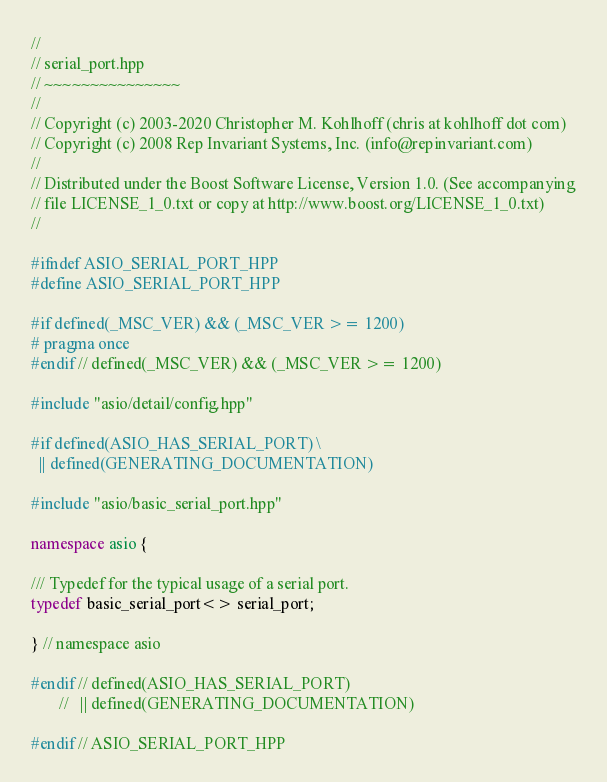<code> <loc_0><loc_0><loc_500><loc_500><_C++_>//
// serial_port.hpp
// ~~~~~~~~~~~~~~~
//
// Copyright (c) 2003-2020 Christopher M. Kohlhoff (chris at kohlhoff dot com)
// Copyright (c) 2008 Rep Invariant Systems, Inc. (info@repinvariant.com)
//
// Distributed under the Boost Software License, Version 1.0. (See accompanying
// file LICENSE_1_0.txt or copy at http://www.boost.org/LICENSE_1_0.txt)
//

#ifndef ASIO_SERIAL_PORT_HPP
#define ASIO_SERIAL_PORT_HPP

#if defined(_MSC_VER) && (_MSC_VER >= 1200)
# pragma once
#endif // defined(_MSC_VER) && (_MSC_VER >= 1200)

#include "asio/detail/config.hpp"

#if defined(ASIO_HAS_SERIAL_PORT) \
  || defined(GENERATING_DOCUMENTATION)

#include "asio/basic_serial_port.hpp"

namespace asio {

/// Typedef for the typical usage of a serial port.
typedef basic_serial_port<> serial_port;

} // namespace asio

#endif // defined(ASIO_HAS_SERIAL_PORT)
       //   || defined(GENERATING_DOCUMENTATION)

#endif // ASIO_SERIAL_PORT_HPP
</code> 